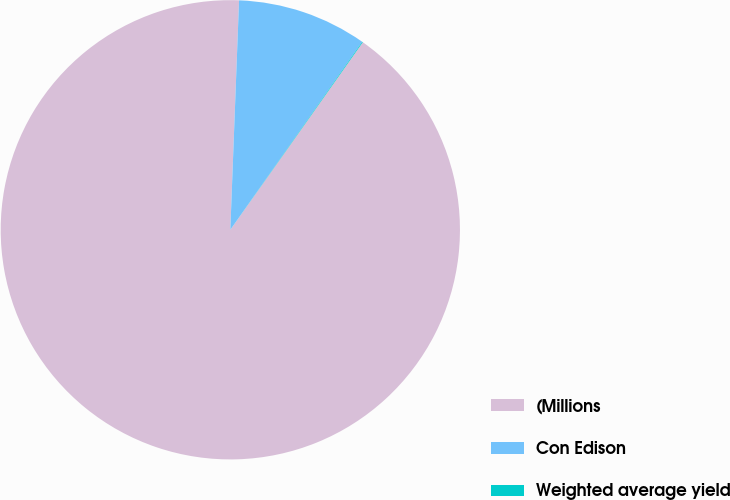Convert chart to OTSL. <chart><loc_0><loc_0><loc_500><loc_500><pie_chart><fcel>(Millions<fcel>Con Edison<fcel>Weighted average yield<nl><fcel>90.82%<fcel>9.13%<fcel>0.05%<nl></chart> 